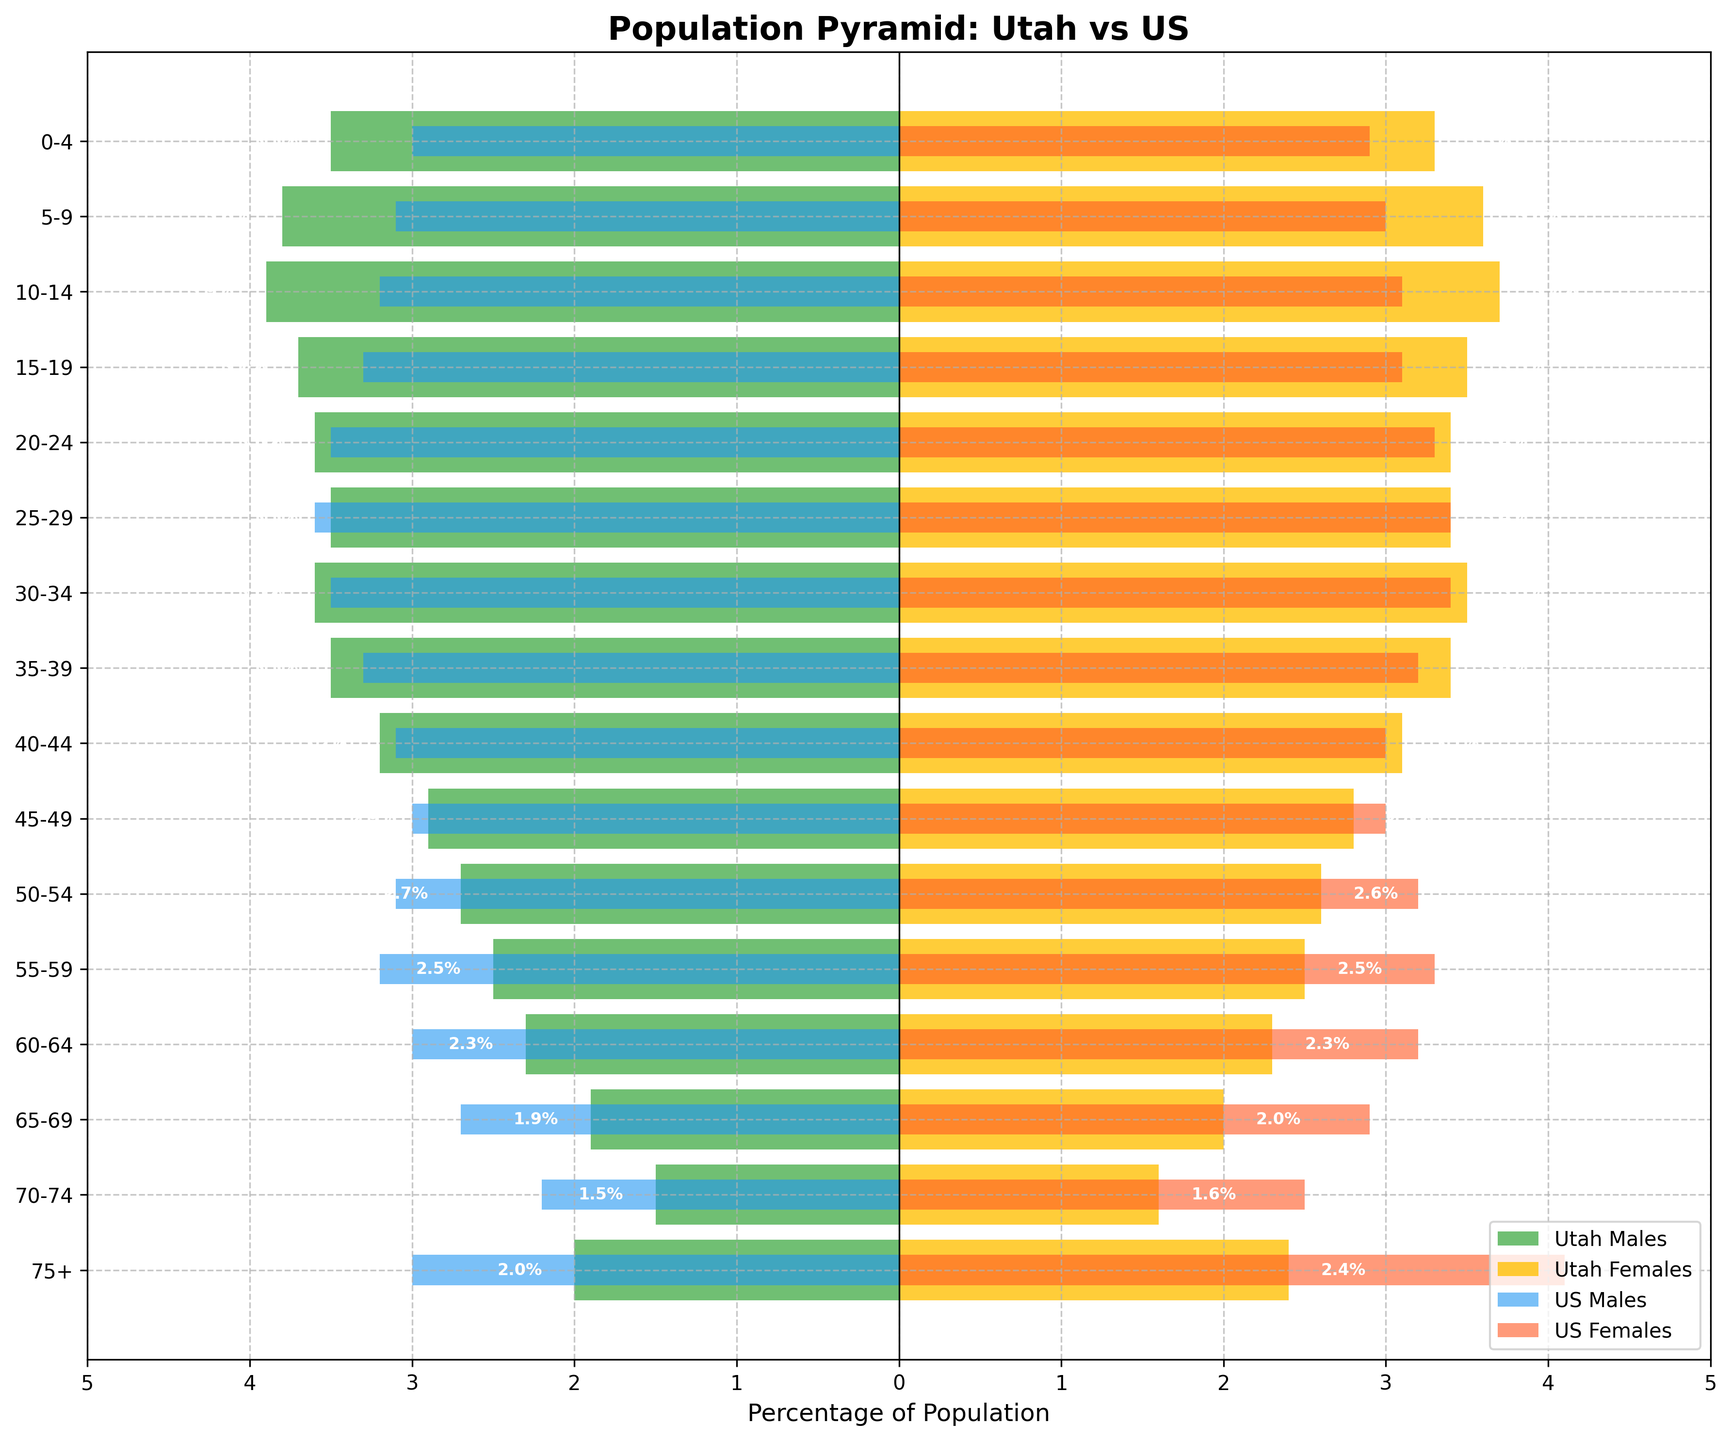What's the title of the figure? The title of the figure is displayed at the top and reads 'Population Pyramid: Utah vs US'.
Answer: 'Population Pyramid: Utah vs US' What percentage of the population are Utah males aged 25-29? The bar for Utah males aged 25-29 extends to -3.5 on the x-axis, representing 3.5% of the population.
Answer: 3.5% Which age group has the largest percentage of Utah males? By comparing the bars on the left (Utah males), the age group 10-14 has the largest percentage at -3.9%.
Answer: 10-14 How do the percentages of US females aged 75+ compare to Utah females of the same age group? The bar for US females aged 75+ reaches 4.1%, while the bar for Utah females of the same group reaches 2.4%. The percentage for US females is higher by 1.7%.
Answer: US females have 1.7% more What's the sum of the percentage for Utah males and females aged 30-34? Utah males aged 30-34 have 3.6% and females have 3.5%. Adding these gives 3.6% + 3.5% = 7.1%.
Answer: 7.1% What's the difference in percentage between Utah males and US males aged 60-64? Utah males aged 60-64 are at 2.3%, whereas US males are at 3.0%. The difference is 3.0% - 2.3% = 0.7%.
Answer: 0.7% In which age group does Utah have the closest percentage of males and females? For several age groups, the percentages for males and females are close. However, the closest can be seen in the age group 55-59, where both are around 2.5%.
Answer: 55-59 How does the percentage of US males aged 0-4 compare to Utah males aged 0-4? The bar for US males aged 0-4 goes to -3.0%, while for Utah males it extends to -3.5%. Thus, Utah males have 0.5% more.
Answer: Utah males have 0.5% more Which group has the smallest percentage on the chart? By checking the lengths of the bars, Utah males and females aged 70-74 have the smallest percentage, which is 1.5% and 1.6% respectively.
Answer: Utah males 70-74 Which age group represents a significant difference in population between Utah females and US females? The comparison indicates that the age group 75+ shows a significant difference as Utah females are 2.4%, and US females are 4.1%, a difference of 1.7%.
Answer: 75+ 